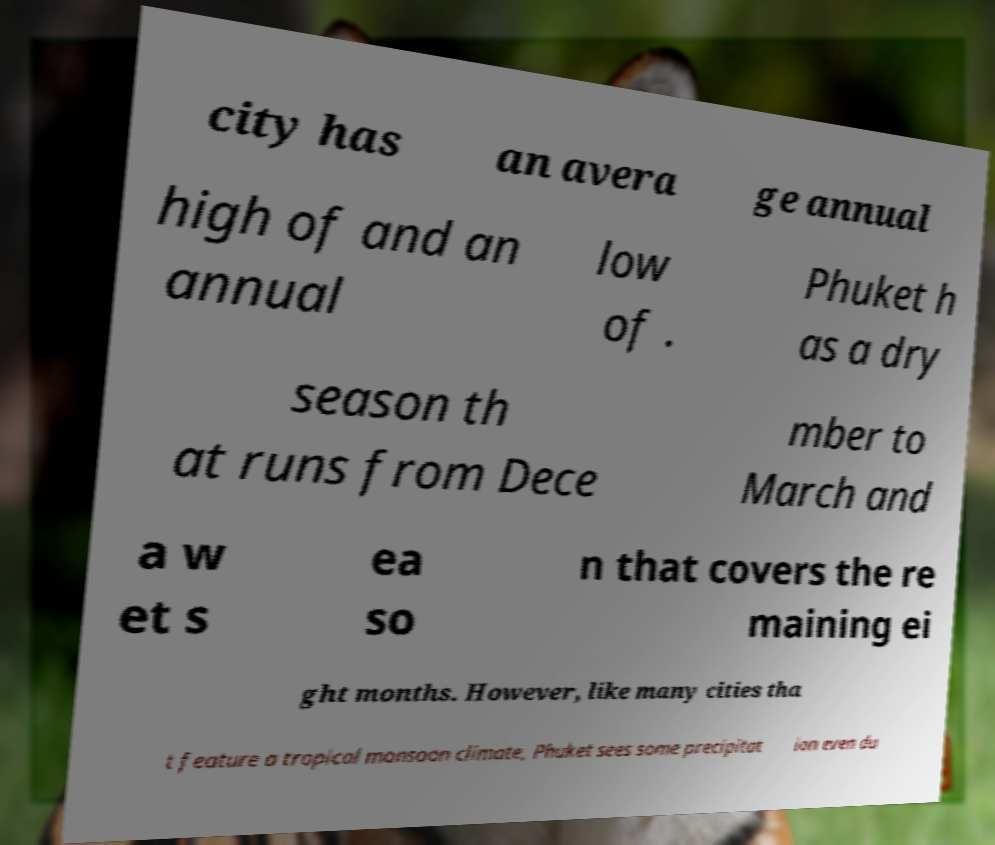Please read and relay the text visible in this image. What does it say? city has an avera ge annual high of and an annual low of . Phuket h as a dry season th at runs from Dece mber to March and a w et s ea so n that covers the re maining ei ght months. However, like many cities tha t feature a tropical monsoon climate, Phuket sees some precipitat ion even du 